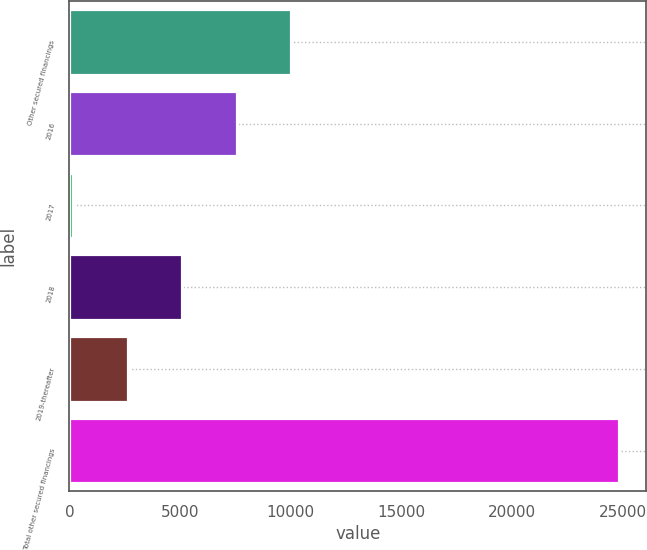<chart> <loc_0><loc_0><loc_500><loc_500><bar_chart><fcel>Other secured financings<fcel>2016<fcel>2017<fcel>2018<fcel>2019-thereafter<fcel>Total other secured financings<nl><fcel>10022.8<fcel>7557.6<fcel>162<fcel>5092.4<fcel>2627.2<fcel>24814<nl></chart> 